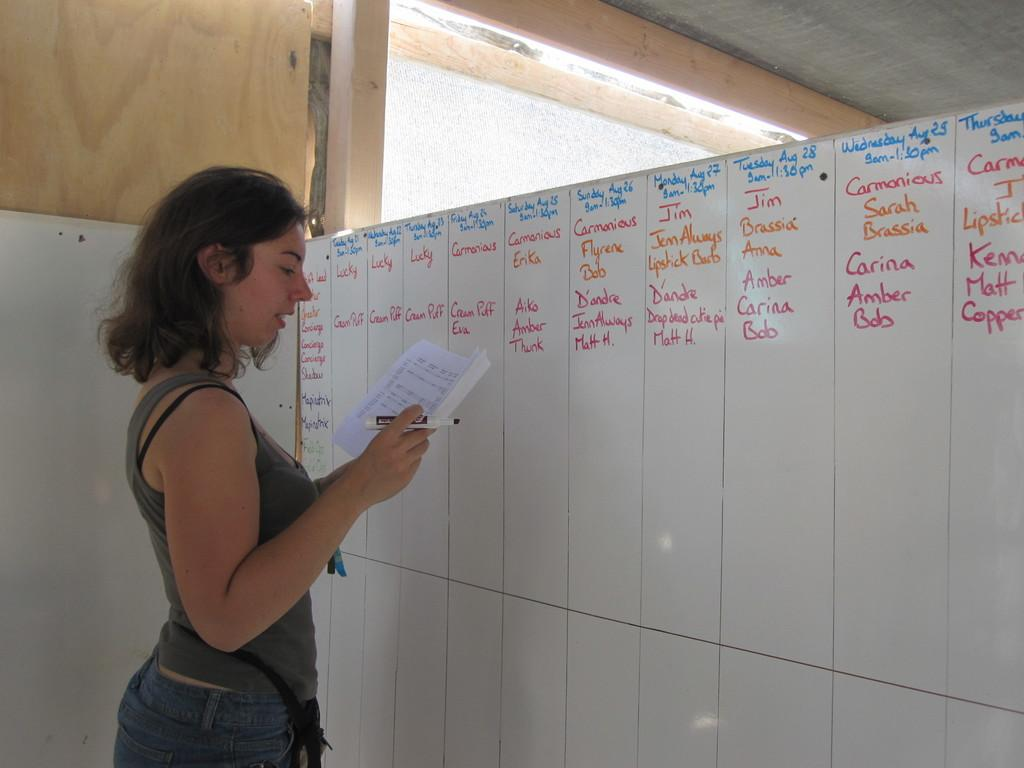Who is present in the image? There is a woman in the image. What is the woman doing in the image? The woman is standing in the image. What is the woman holding in her hand? The woman is holding a paper in her hand. What can be seen in the background of the image? There is a board in the background of the image. What type of cap is the woman wearing in the image? There is no cap visible in the image; the woman is not wearing one. What color is the pencil the woman is using to write on the paper? There is no pencil present in the image; the woman is holding a paper, but there is no indication that she is writing or using a pencil. 